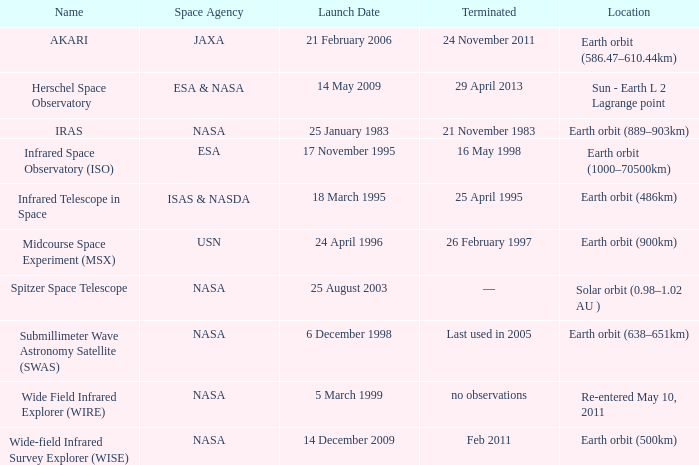Which space agency launched the herschel space observatory? ESA & NASA. 